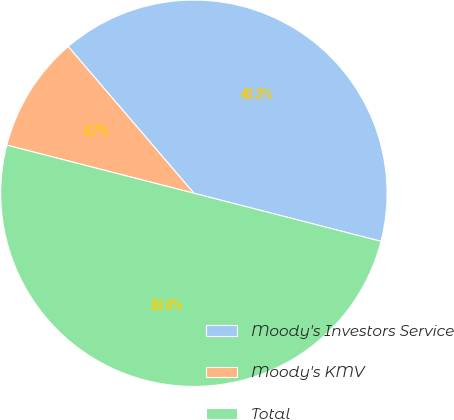Convert chart to OTSL. <chart><loc_0><loc_0><loc_500><loc_500><pie_chart><fcel>Moody's Investors Service<fcel>Moody's KMV<fcel>Total<nl><fcel>40.28%<fcel>9.72%<fcel>50.0%<nl></chart> 